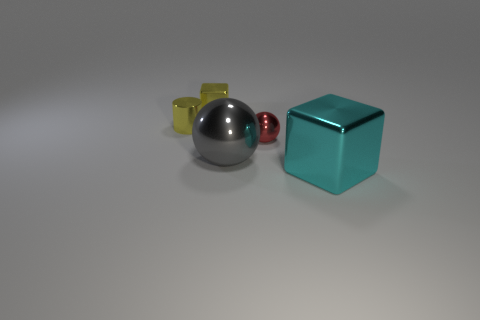There is a big metal block; is its color the same as the metal ball behind the big gray metal ball?
Provide a succinct answer. No. There is a small thing that is on the right side of the big shiny object left of the large cyan shiny block; what is its color?
Your answer should be compact. Red. The metallic cylinder that is the same size as the yellow cube is what color?
Offer a very short reply. Yellow. Is there another shiny object that has the same shape as the small red object?
Your answer should be compact. Yes. What is the shape of the big cyan shiny thing?
Offer a very short reply. Cube. Are there more yellow cubes right of the yellow shiny block than small yellow blocks that are in front of the small metallic cylinder?
Your response must be concise. No. How many other things are the same size as the cyan cube?
Your answer should be very brief. 1. What is the material of the small thing that is to the left of the gray object and on the right side of the tiny cylinder?
Provide a succinct answer. Metal. There is a tiny yellow thing that is the same shape as the big cyan metal object; what is it made of?
Make the answer very short. Metal. There is a metal cube that is to the right of the yellow shiny object that is behind the small cylinder; how many small metal things are to the right of it?
Offer a terse response. 0. 